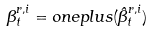<formula> <loc_0><loc_0><loc_500><loc_500>\beta _ { t } ^ { r , i } = { o n e p l u s } ( { \hat { \beta } } _ { t } ^ { r , i } )</formula> 